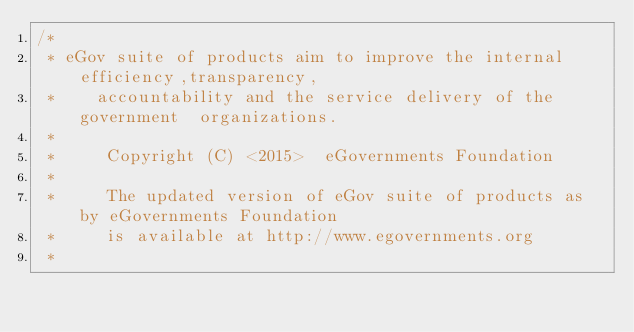Convert code to text. <code><loc_0><loc_0><loc_500><loc_500><_Java_>/*
 * eGov suite of products aim to improve the internal efficiency,transparency,
 *    accountability and the service delivery of the government  organizations.
 *
 *     Copyright (C) <2015>  eGovernments Foundation
 *
 *     The updated version of eGov suite of products as by eGovernments Foundation
 *     is available at http://www.egovernments.org
 *</code> 